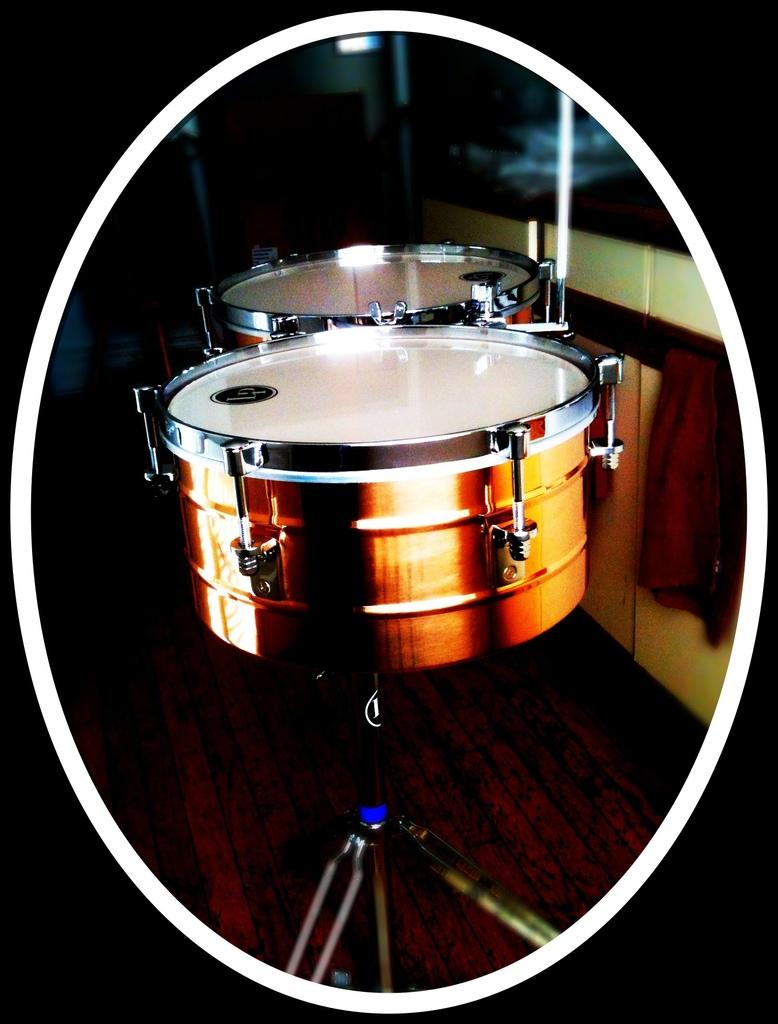What objects are present in the image? There are musical instruments in the image. What type of surface is the musical instruments placed on? The musical instruments are on a wooden floor. How many grapes are hanging from the musical instruments in the image? There are no grapes present in the image; it only features musical instruments on a wooden floor. 